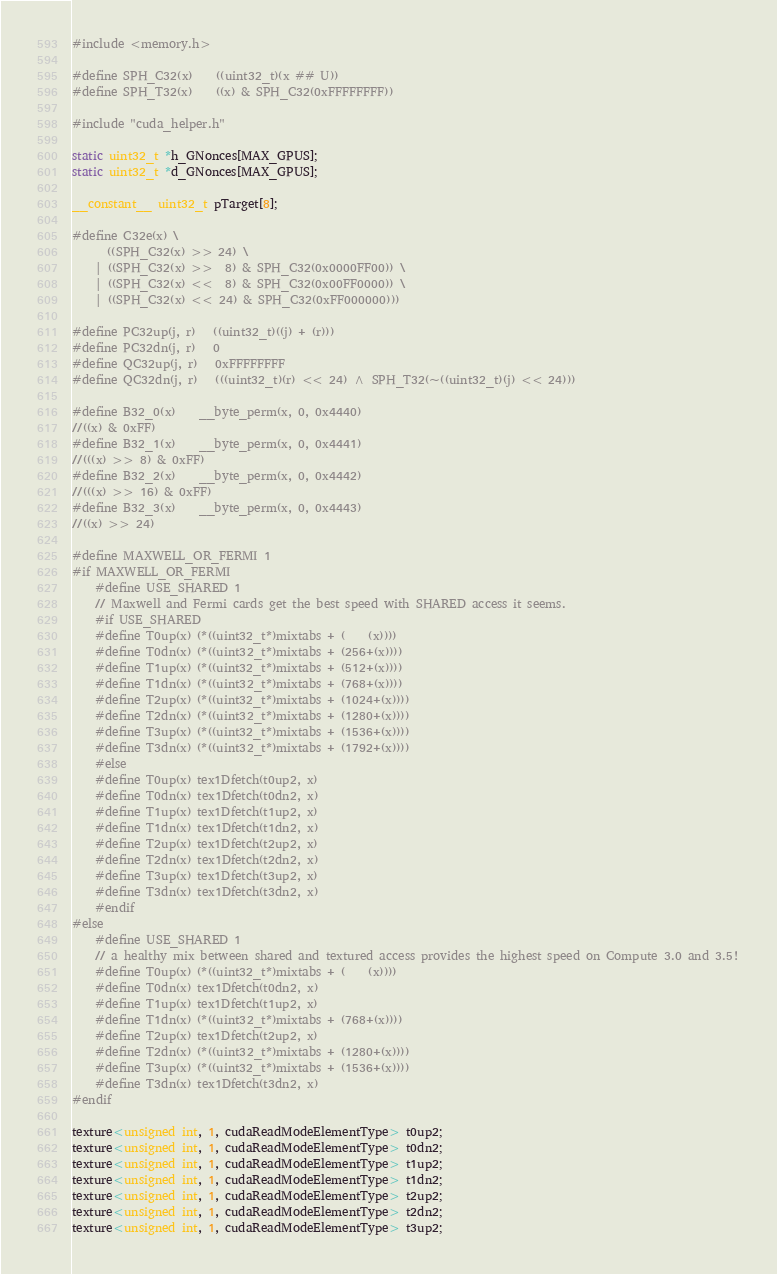<code> <loc_0><loc_0><loc_500><loc_500><_Cuda_>#include <memory.h>

#define SPH_C32(x)    ((uint32_t)(x ## U))
#define SPH_T32(x)    ((x) & SPH_C32(0xFFFFFFFF))

#include "cuda_helper.h"

static uint32_t *h_GNonces[MAX_GPUS];
static uint32_t *d_GNonces[MAX_GPUS];

__constant__ uint32_t pTarget[8];

#define C32e(x) \
	  ((SPH_C32(x) >> 24) \
	| ((SPH_C32(x) >>  8) & SPH_C32(0x0000FF00)) \
	| ((SPH_C32(x) <<  8) & SPH_C32(0x00FF0000)) \
	| ((SPH_C32(x) << 24) & SPH_C32(0xFF000000)))

#define PC32up(j, r)   ((uint32_t)((j) + (r)))
#define PC32dn(j, r)   0
#define QC32up(j, r)   0xFFFFFFFF
#define QC32dn(j, r)   (((uint32_t)(r) << 24) ^ SPH_T32(~((uint32_t)(j) << 24)))

#define B32_0(x)    __byte_perm(x, 0, 0x4440)
//((x) & 0xFF)
#define B32_1(x)    __byte_perm(x, 0, 0x4441)
//(((x) >> 8) & 0xFF)
#define B32_2(x)    __byte_perm(x, 0, 0x4442)
//(((x) >> 16) & 0xFF)
#define B32_3(x)    __byte_perm(x, 0, 0x4443)
//((x) >> 24)

#define MAXWELL_OR_FERMI 1
#if MAXWELL_OR_FERMI
	#define USE_SHARED 1
	// Maxwell and Fermi cards get the best speed with SHARED access it seems.
	#if USE_SHARED
	#define T0up(x) (*((uint32_t*)mixtabs + (    (x))))
	#define T0dn(x) (*((uint32_t*)mixtabs + (256+(x))))
	#define T1up(x) (*((uint32_t*)mixtabs + (512+(x))))
	#define T1dn(x) (*((uint32_t*)mixtabs + (768+(x))))
	#define T2up(x) (*((uint32_t*)mixtabs + (1024+(x))))
	#define T2dn(x) (*((uint32_t*)mixtabs + (1280+(x))))
	#define T3up(x) (*((uint32_t*)mixtabs + (1536+(x))))
	#define T3dn(x) (*((uint32_t*)mixtabs + (1792+(x))))
	#else
	#define T0up(x) tex1Dfetch(t0up2, x)
	#define T0dn(x) tex1Dfetch(t0dn2, x)
	#define T1up(x) tex1Dfetch(t1up2, x)
	#define T1dn(x) tex1Dfetch(t1dn2, x)
	#define T2up(x) tex1Dfetch(t2up2, x)
	#define T2dn(x) tex1Dfetch(t2dn2, x)
	#define T3up(x) tex1Dfetch(t3up2, x)
	#define T3dn(x) tex1Dfetch(t3dn2, x)
	#endif
#else
	#define USE_SHARED 1
	// a healthy mix between shared and textured access provides the highest speed on Compute 3.0 and 3.5!
	#define T0up(x) (*((uint32_t*)mixtabs + (    (x))))
	#define T0dn(x) tex1Dfetch(t0dn2, x)
	#define T1up(x) tex1Dfetch(t1up2, x)
	#define T1dn(x) (*((uint32_t*)mixtabs + (768+(x))))
	#define T2up(x) tex1Dfetch(t2up2, x)
	#define T2dn(x) (*((uint32_t*)mixtabs + (1280+(x))))
	#define T3up(x) (*((uint32_t*)mixtabs + (1536+(x))))
	#define T3dn(x) tex1Dfetch(t3dn2, x)
#endif

texture<unsigned int, 1, cudaReadModeElementType> t0up2;
texture<unsigned int, 1, cudaReadModeElementType> t0dn2;
texture<unsigned int, 1, cudaReadModeElementType> t1up2;
texture<unsigned int, 1, cudaReadModeElementType> t1dn2;
texture<unsigned int, 1, cudaReadModeElementType> t2up2;
texture<unsigned int, 1, cudaReadModeElementType> t2dn2;
texture<unsigned int, 1, cudaReadModeElementType> t3up2;</code> 